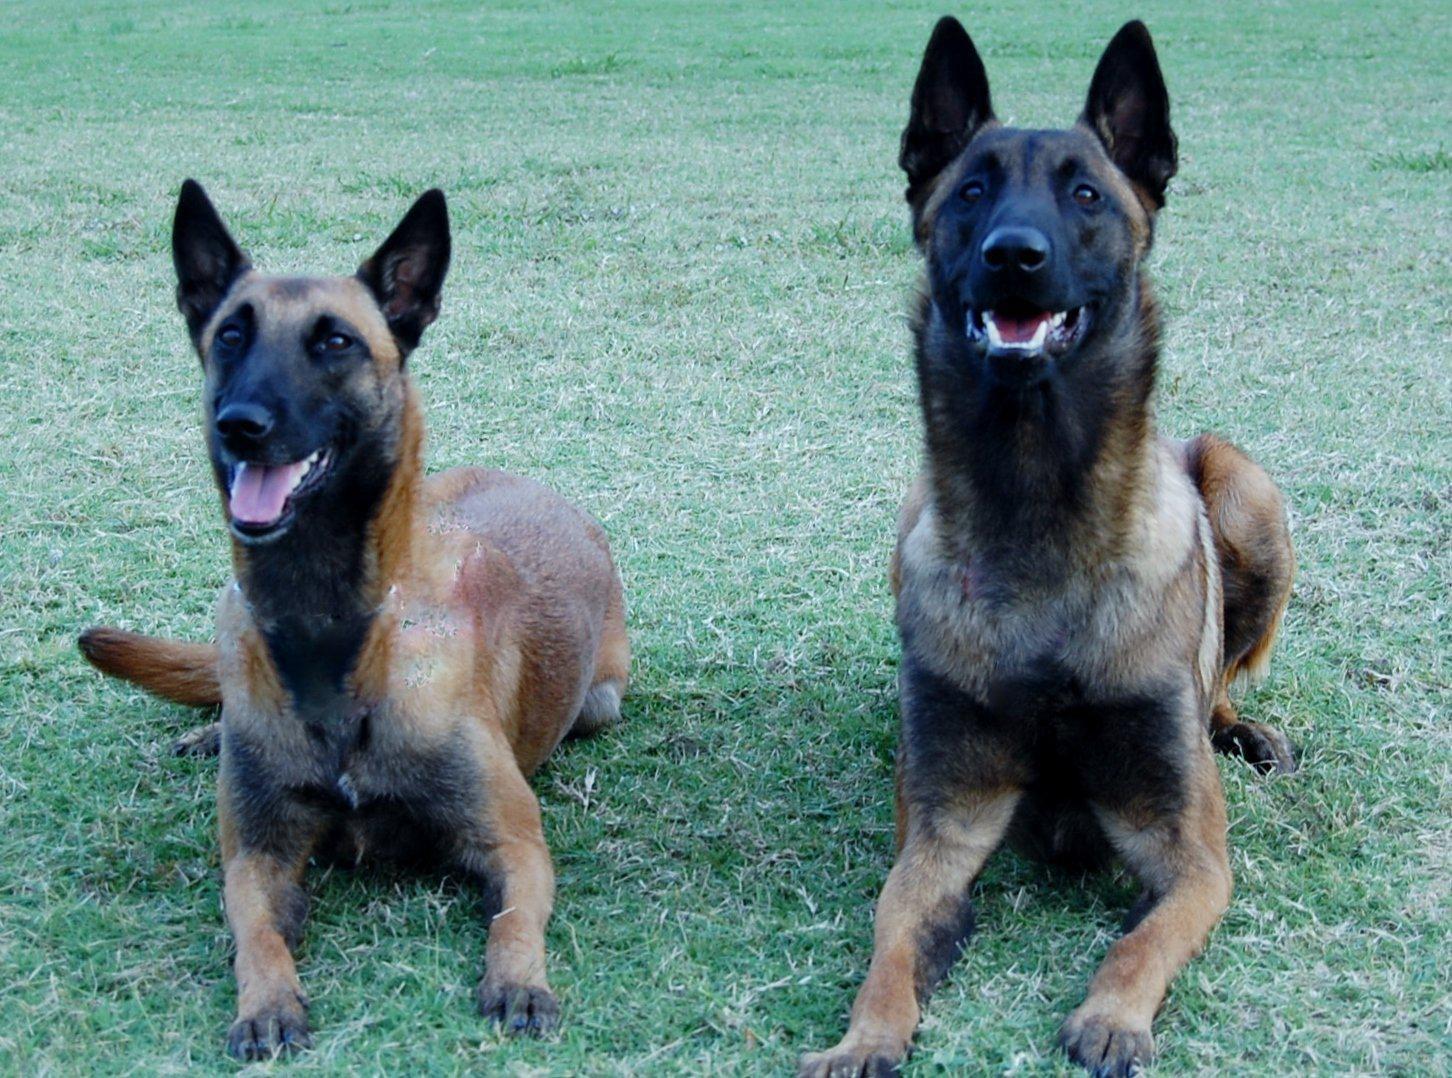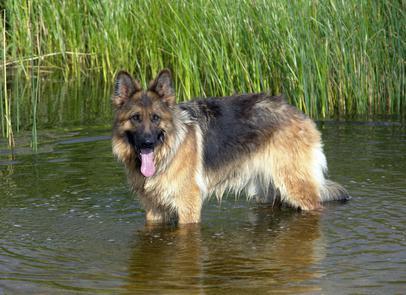The first image is the image on the left, the second image is the image on the right. For the images displayed, is the sentence "Each image contains a single german shepherd, and each dog wears a leash." factually correct? Answer yes or no. No. 